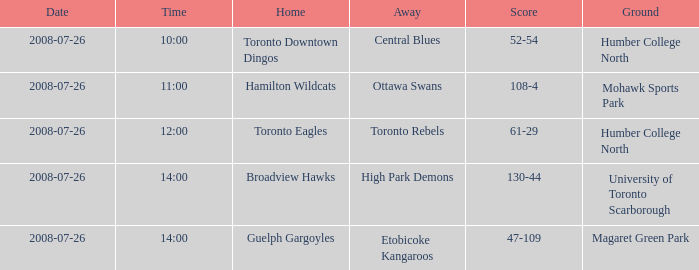When did the High Park Demons play Away? 2008-07-26. 